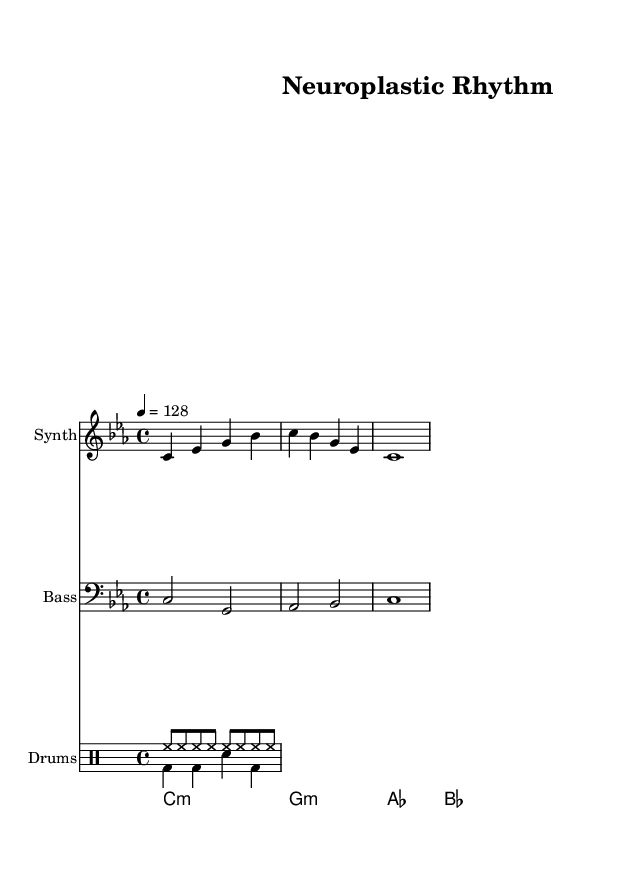What is the key signature of this music? The key signature is C minor, which typically includes E flat, A flat, and B flat. This can be identified in the first measure of the score, where the key signature is placed.
Answer: C minor What is the time signature of this music? The time signature is specified at the beginning of the score, which shows 4/4. This means there are four beats in each measure and a quarter note receives one beat.
Answer: 4/4 What tempo is indicated for this piece? The tempo marking shows "4 = 128," indicating that there are 128 beats per minute in this piece. The number indicates the metronome marking for the quarter note.
Answer: 128 How many measures are in the main melody? The main melody consists of 3 measures, as shown by counting the vertical bars that separate each measure in the synth melody staff.
Answer: 3 What type of drum pattern is primarily used in this piece? The drum pattern consists of a hi-hat rhythm in the first voice and a kick and snare pattern in the second voice. The hi-hat is in eighth notes, while the kick and snare occur in a 4/4 pattern.
Answer: Hi-hat and kick/snare What are the first three chords in the pad section? The first three chords shown in the score are C minor, G minor, and A flat major. These chords can be identified in the chord names staff.
Answer: C minor, G minor, A flat major How does the bassline complement the melody? The bassline plays sustained notes that follow the root notes of the chords indicated, reinforcing the harmonic structure while providing a rhythmic foundation in half notes.
Answer: By reinforcing the harmonic structure 